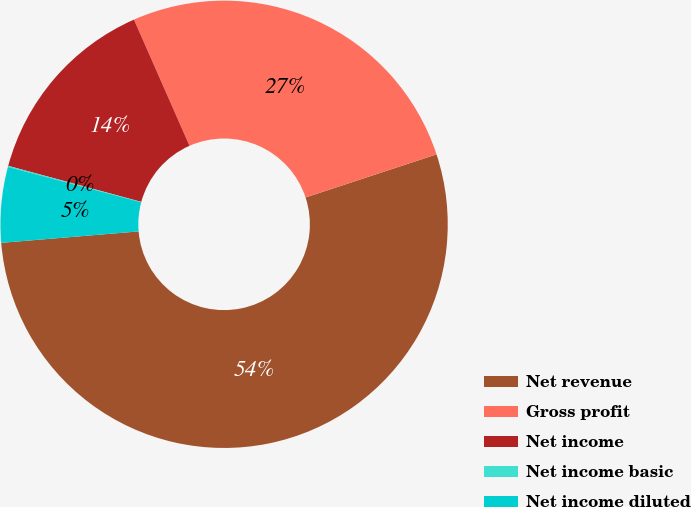Convert chart to OTSL. <chart><loc_0><loc_0><loc_500><loc_500><pie_chart><fcel>Net revenue<fcel>Gross profit<fcel>Net income<fcel>Net income basic<fcel>Net income diluted<nl><fcel>53.74%<fcel>26.54%<fcel>14.19%<fcel>0.08%<fcel>5.45%<nl></chart> 